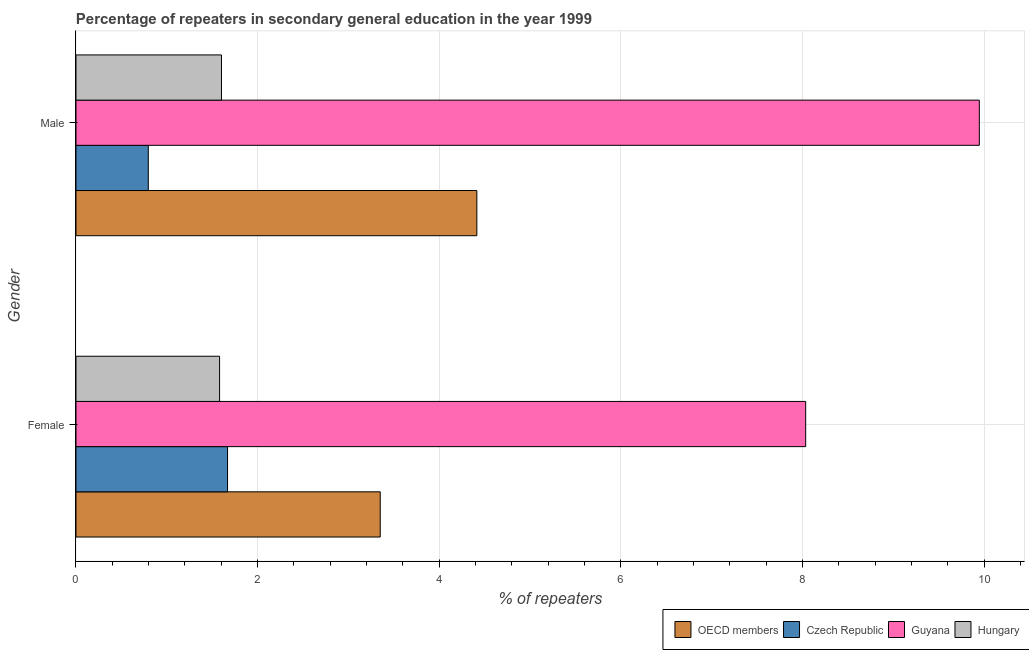How many groups of bars are there?
Offer a very short reply. 2. Are the number of bars per tick equal to the number of legend labels?
Your response must be concise. Yes. Are the number of bars on each tick of the Y-axis equal?
Make the answer very short. Yes. How many bars are there on the 2nd tick from the bottom?
Ensure brevity in your answer.  4. What is the percentage of female repeaters in OECD members?
Your answer should be very brief. 3.35. Across all countries, what is the maximum percentage of female repeaters?
Your answer should be compact. 8.03. Across all countries, what is the minimum percentage of male repeaters?
Offer a very short reply. 0.8. In which country was the percentage of female repeaters maximum?
Give a very brief answer. Guyana. In which country was the percentage of female repeaters minimum?
Give a very brief answer. Hungary. What is the total percentage of female repeaters in the graph?
Make the answer very short. 14.63. What is the difference between the percentage of female repeaters in OECD members and that in Czech Republic?
Offer a terse response. 1.68. What is the difference between the percentage of male repeaters in OECD members and the percentage of female repeaters in Guyana?
Make the answer very short. -3.62. What is the average percentage of female repeaters per country?
Your answer should be compact. 3.66. What is the difference between the percentage of male repeaters and percentage of female repeaters in Czech Republic?
Ensure brevity in your answer.  -0.87. What is the ratio of the percentage of female repeaters in Hungary to that in OECD members?
Your answer should be compact. 0.47. Is the percentage of female repeaters in Guyana less than that in Hungary?
Offer a terse response. No. In how many countries, is the percentage of female repeaters greater than the average percentage of female repeaters taken over all countries?
Ensure brevity in your answer.  1. What does the 3rd bar from the top in Male represents?
Your response must be concise. Czech Republic. How many bars are there?
Make the answer very short. 8. Are the values on the major ticks of X-axis written in scientific E-notation?
Make the answer very short. No. Does the graph contain any zero values?
Provide a succinct answer. No. Does the graph contain grids?
Give a very brief answer. Yes. How many legend labels are there?
Keep it short and to the point. 4. How are the legend labels stacked?
Offer a terse response. Horizontal. What is the title of the graph?
Provide a succinct answer. Percentage of repeaters in secondary general education in the year 1999. Does "Nepal" appear as one of the legend labels in the graph?
Provide a short and direct response. No. What is the label or title of the X-axis?
Your answer should be compact. % of repeaters. What is the % of repeaters of OECD members in Female?
Make the answer very short. 3.35. What is the % of repeaters in Czech Republic in Female?
Keep it short and to the point. 1.67. What is the % of repeaters of Guyana in Female?
Keep it short and to the point. 8.03. What is the % of repeaters in Hungary in Female?
Your response must be concise. 1.58. What is the % of repeaters of OECD members in Male?
Provide a succinct answer. 4.41. What is the % of repeaters in Czech Republic in Male?
Your answer should be compact. 0.8. What is the % of repeaters of Guyana in Male?
Offer a terse response. 9.95. What is the % of repeaters in Hungary in Male?
Keep it short and to the point. 1.6. Across all Gender, what is the maximum % of repeaters in OECD members?
Your answer should be very brief. 4.41. Across all Gender, what is the maximum % of repeaters in Czech Republic?
Your answer should be compact. 1.67. Across all Gender, what is the maximum % of repeaters in Guyana?
Offer a terse response. 9.95. Across all Gender, what is the maximum % of repeaters of Hungary?
Make the answer very short. 1.6. Across all Gender, what is the minimum % of repeaters of OECD members?
Offer a terse response. 3.35. Across all Gender, what is the minimum % of repeaters of Czech Republic?
Provide a succinct answer. 0.8. Across all Gender, what is the minimum % of repeaters of Guyana?
Provide a short and direct response. 8.03. Across all Gender, what is the minimum % of repeaters of Hungary?
Ensure brevity in your answer.  1.58. What is the total % of repeaters in OECD members in the graph?
Your answer should be very brief. 7.76. What is the total % of repeaters in Czech Republic in the graph?
Make the answer very short. 2.46. What is the total % of repeaters in Guyana in the graph?
Your response must be concise. 17.98. What is the total % of repeaters in Hungary in the graph?
Keep it short and to the point. 3.18. What is the difference between the % of repeaters of OECD members in Female and that in Male?
Your response must be concise. -1.06. What is the difference between the % of repeaters in Czech Republic in Female and that in Male?
Give a very brief answer. 0.87. What is the difference between the % of repeaters in Guyana in Female and that in Male?
Provide a short and direct response. -1.91. What is the difference between the % of repeaters in Hungary in Female and that in Male?
Offer a very short reply. -0.02. What is the difference between the % of repeaters in OECD members in Female and the % of repeaters in Czech Republic in Male?
Give a very brief answer. 2.55. What is the difference between the % of repeaters of OECD members in Female and the % of repeaters of Guyana in Male?
Your answer should be very brief. -6.6. What is the difference between the % of repeaters in OECD members in Female and the % of repeaters in Hungary in Male?
Offer a terse response. 1.75. What is the difference between the % of repeaters in Czech Republic in Female and the % of repeaters in Guyana in Male?
Your response must be concise. -8.28. What is the difference between the % of repeaters of Czech Republic in Female and the % of repeaters of Hungary in Male?
Offer a terse response. 0.07. What is the difference between the % of repeaters of Guyana in Female and the % of repeaters of Hungary in Male?
Provide a short and direct response. 6.43. What is the average % of repeaters of OECD members per Gender?
Ensure brevity in your answer.  3.88. What is the average % of repeaters in Czech Republic per Gender?
Your answer should be very brief. 1.23. What is the average % of repeaters in Guyana per Gender?
Offer a terse response. 8.99. What is the average % of repeaters in Hungary per Gender?
Give a very brief answer. 1.59. What is the difference between the % of repeaters of OECD members and % of repeaters of Czech Republic in Female?
Your response must be concise. 1.68. What is the difference between the % of repeaters in OECD members and % of repeaters in Guyana in Female?
Give a very brief answer. -4.68. What is the difference between the % of repeaters of OECD members and % of repeaters of Hungary in Female?
Your response must be concise. 1.77. What is the difference between the % of repeaters of Czech Republic and % of repeaters of Guyana in Female?
Your answer should be compact. -6.37. What is the difference between the % of repeaters in Czech Republic and % of repeaters in Hungary in Female?
Keep it short and to the point. 0.09. What is the difference between the % of repeaters in Guyana and % of repeaters in Hungary in Female?
Provide a succinct answer. 6.45. What is the difference between the % of repeaters of OECD members and % of repeaters of Czech Republic in Male?
Make the answer very short. 3.62. What is the difference between the % of repeaters of OECD members and % of repeaters of Guyana in Male?
Give a very brief answer. -5.53. What is the difference between the % of repeaters of OECD members and % of repeaters of Hungary in Male?
Provide a short and direct response. 2.81. What is the difference between the % of repeaters of Czech Republic and % of repeaters of Guyana in Male?
Keep it short and to the point. -9.15. What is the difference between the % of repeaters of Czech Republic and % of repeaters of Hungary in Male?
Provide a succinct answer. -0.81. What is the difference between the % of repeaters in Guyana and % of repeaters in Hungary in Male?
Your answer should be very brief. 8.34. What is the ratio of the % of repeaters of OECD members in Female to that in Male?
Keep it short and to the point. 0.76. What is the ratio of the % of repeaters of Czech Republic in Female to that in Male?
Provide a short and direct response. 2.1. What is the ratio of the % of repeaters of Guyana in Female to that in Male?
Ensure brevity in your answer.  0.81. What is the difference between the highest and the second highest % of repeaters in OECD members?
Offer a terse response. 1.06. What is the difference between the highest and the second highest % of repeaters of Czech Republic?
Your answer should be compact. 0.87. What is the difference between the highest and the second highest % of repeaters in Guyana?
Provide a short and direct response. 1.91. What is the difference between the highest and the second highest % of repeaters of Hungary?
Your answer should be compact. 0.02. What is the difference between the highest and the lowest % of repeaters of OECD members?
Offer a very short reply. 1.06. What is the difference between the highest and the lowest % of repeaters of Czech Republic?
Offer a terse response. 0.87. What is the difference between the highest and the lowest % of repeaters in Guyana?
Ensure brevity in your answer.  1.91. What is the difference between the highest and the lowest % of repeaters of Hungary?
Give a very brief answer. 0.02. 